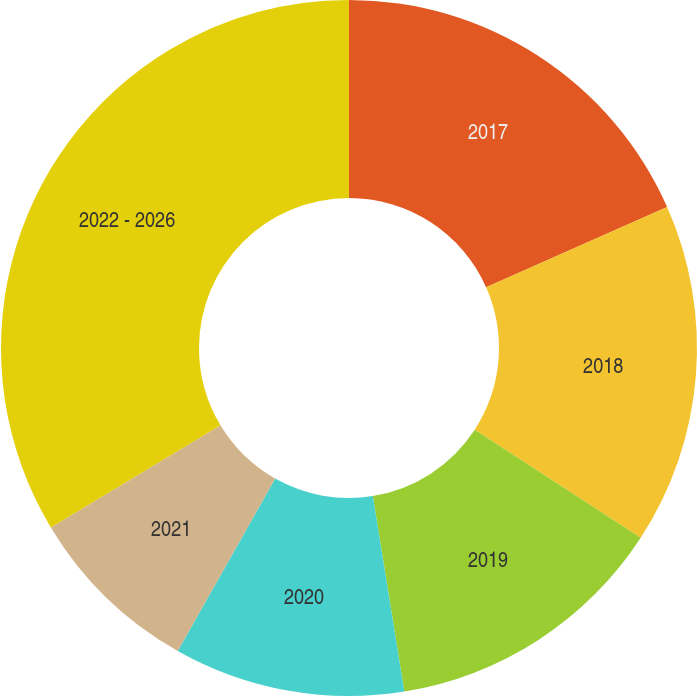Convert chart. <chart><loc_0><loc_0><loc_500><loc_500><pie_chart><fcel>2017<fcel>2018<fcel>2019<fcel>2020<fcel>2021<fcel>2022 - 2026<nl><fcel>18.36%<fcel>15.82%<fcel>13.28%<fcel>10.73%<fcel>8.19%<fcel>33.62%<nl></chart> 